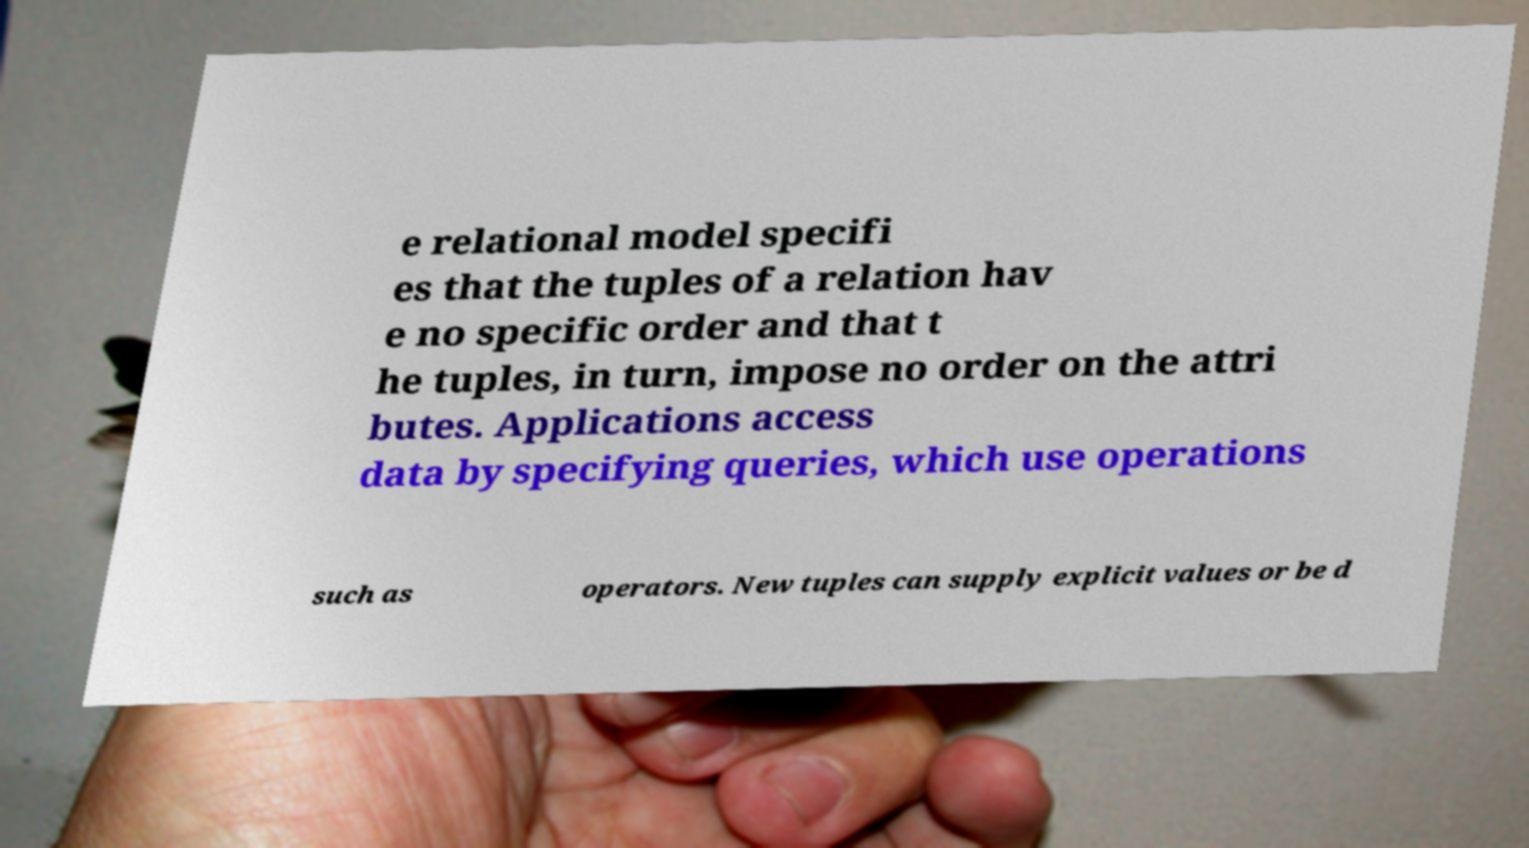There's text embedded in this image that I need extracted. Can you transcribe it verbatim? e relational model specifi es that the tuples of a relation hav e no specific order and that t he tuples, in turn, impose no order on the attri butes. Applications access data by specifying queries, which use operations such as operators. New tuples can supply explicit values or be d 